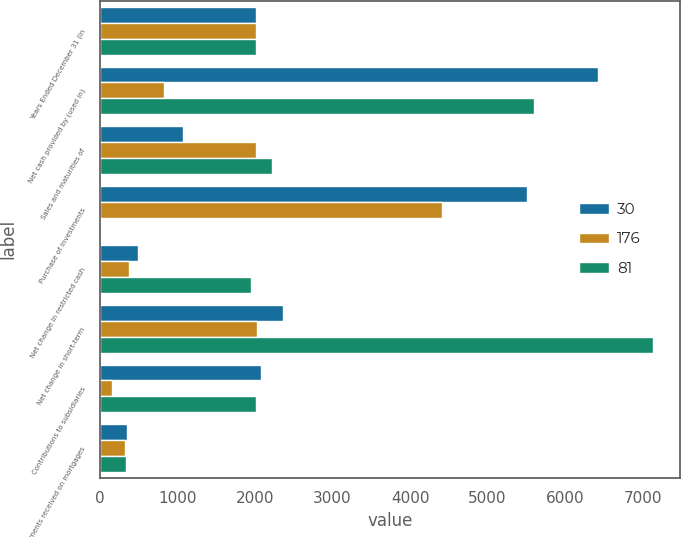Convert chart to OTSL. <chart><loc_0><loc_0><loc_500><loc_500><stacked_bar_chart><ecel><fcel>Years Ended December 31 (in<fcel>Net cash provided by (used in)<fcel>Sales and maturities of<fcel>Purchase of investments<fcel>Net change in restricted cash<fcel>Net change in short-term<fcel>Contributions to subsidiaries<fcel>Payments received on mortgages<nl><fcel>30<fcel>2013<fcel>6422<fcel>1074<fcel>5506<fcel>493<fcel>2361<fcel>2081<fcel>351<nl><fcel>176<fcel>2012<fcel>825<fcel>2011.5<fcel>4406<fcel>377<fcel>2029<fcel>152<fcel>328<nl><fcel>81<fcel>2011<fcel>5600<fcel>2224<fcel>19<fcel>1945<fcel>7130<fcel>2011.5<fcel>341<nl></chart> 